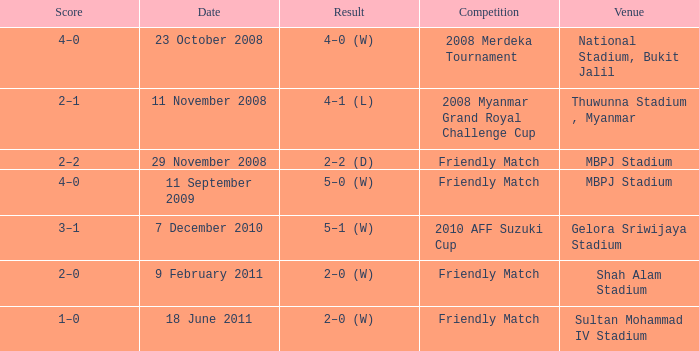What is the Venue of the Competition with a Result of 2–2 (d)? MBPJ Stadium. 